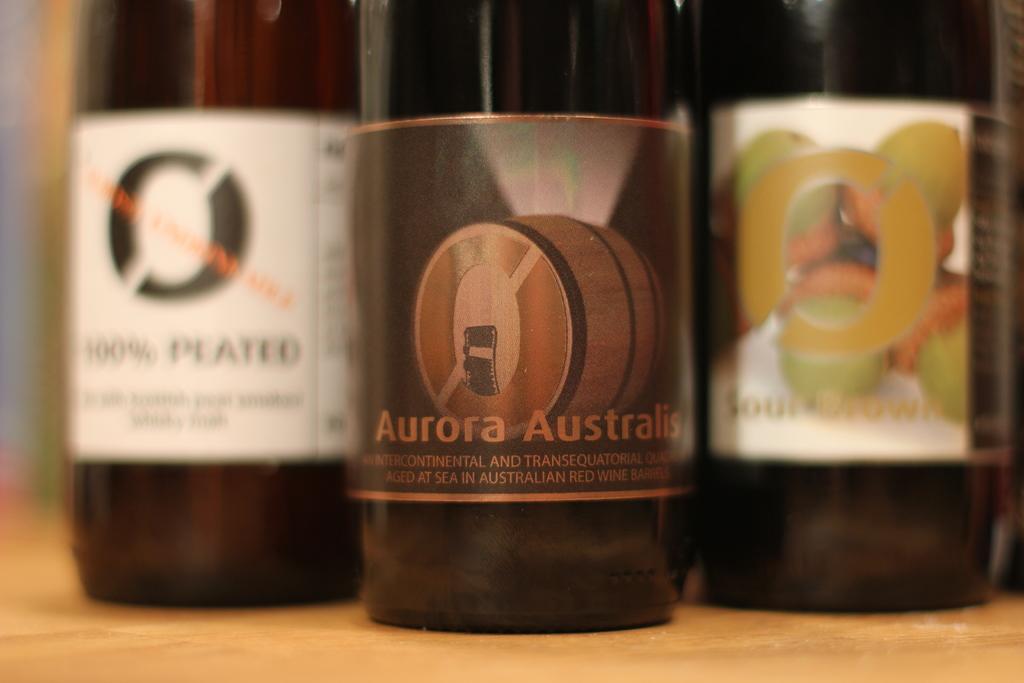What country can be seen on the bottle?
Your answer should be very brief. Australia. 